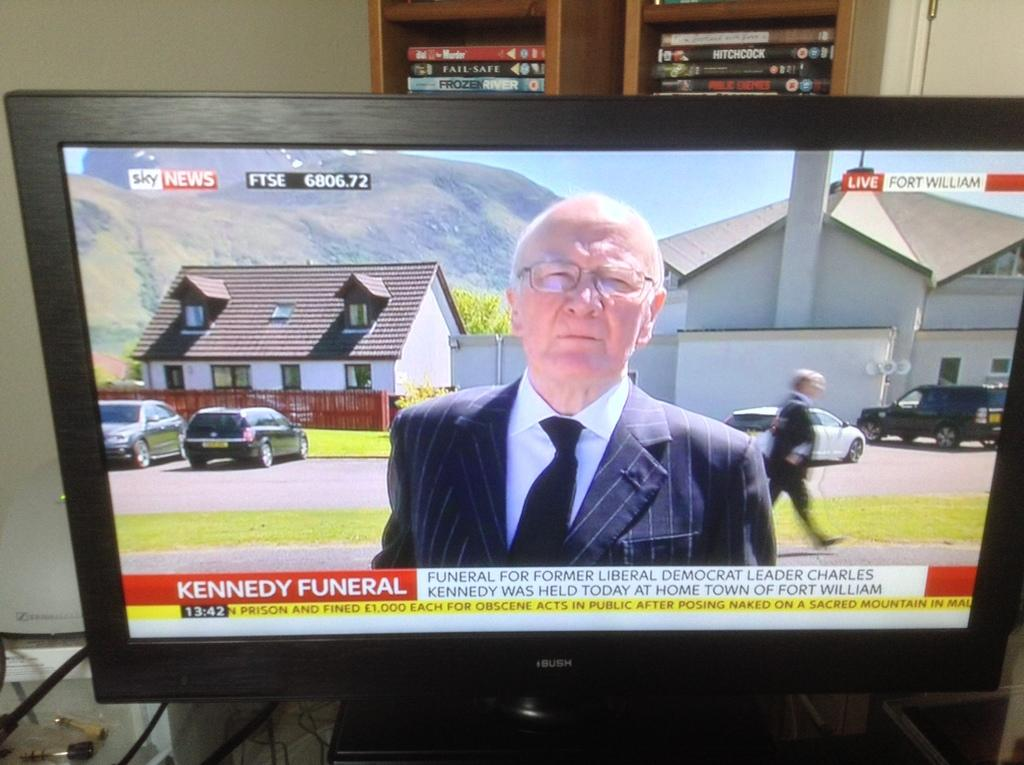<image>
Give a short and clear explanation of the subsequent image. Sky news is reporting on the funeral of Charles Kennedy. 